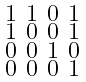Convert formula to latex. <formula><loc_0><loc_0><loc_500><loc_500>\begin{smallmatrix} 1 & 1 & 0 & 1 \\ 1 & 0 & 0 & 1 \\ 0 & 0 & 1 & 0 \\ 0 & 0 & 0 & 1 \\ \end{smallmatrix}</formula> 